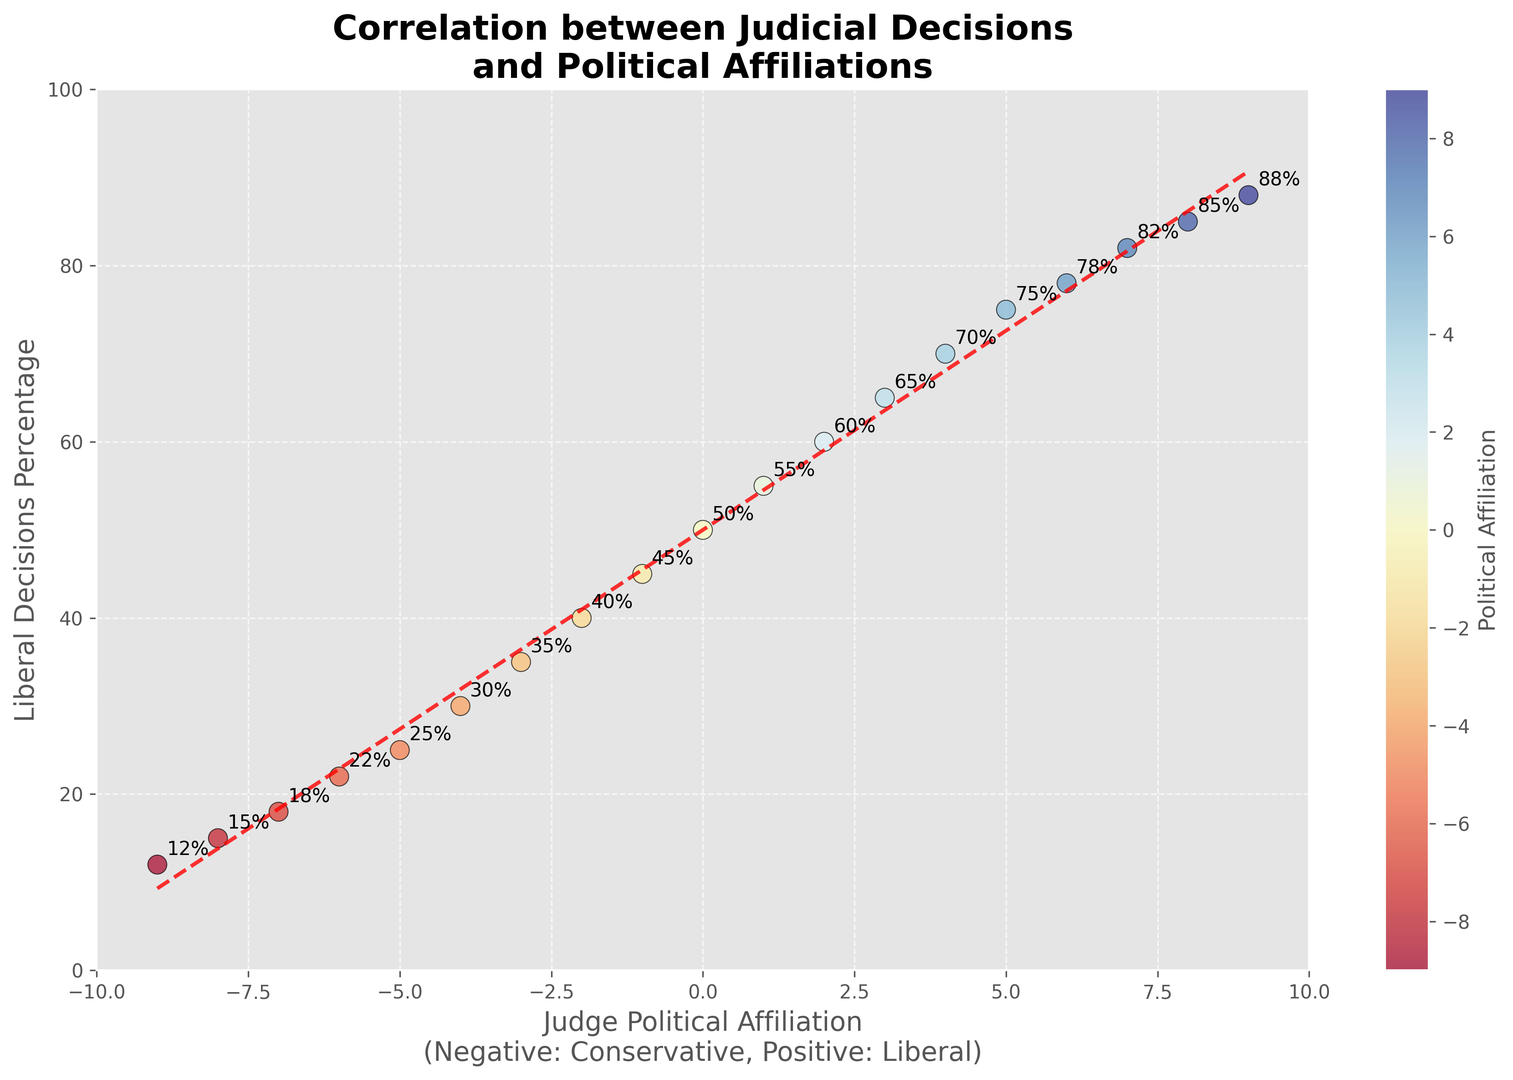What's the overall trend in the percentage of liberal decisions as the judge's political affiliation becomes more liberal? The trend can be seen from the scatter plot where liberal decisions percentage increases as the judge's political affiliation moves from conservative (negative values) to liberal (positive values). This trend is emphasized by the red dashed line (linear fit) in the plot.
Answer: Increases What range of political affiliations shows judges making around 50% liberal decisions? Observing the scatter plot, judges with political affiliations near 0 (neutral) make around 50% liberal decisions.
Answer: Around 0 Which judge political affiliation has the highest percentage of liberal decisions? The scatter plot indicates that the highest percentage of liberal decisions, 88%, corresponds to the judge with a political affiliation of 9.
Answer: 9 Can you identify the approximate slope of the red dashed trend line? By looking at the red dashed trend line (linear fit), the slope can be roughly estimated. It seems to rise by about 10 units on the y-axis for every 1 unit on the x-axis. The actual slope might be around 8-10.
Answer: 8-10 Is the trend between political affiliation and liberal decisions positive or negative? The red dashed trend line shows an upward trajectory from left to right, indicating a positive correlation between political affiliation and liberal decisions.
Answer: Positive Which judge political affiliation corresponds to around 75% of liberal decisions? According to the scatter plot, around 75% of liberal decisions correspond to the political affiliation of around 5.
Answer: 5 How does the liberal decisions percentage vary among judges with political affiliations between -5 and 5? Observing this range on the scatter plot, judges with political affiliations between -5 and 5 have their liberal decisions percentages increasing from 25% to 75%.
Answer: 25% to 75% What does the color gradient in the scatter plot represent? The color gradient in the scatter plot represents the political affiliation of the judges, ranging from blue (conservative) to red (liberal) through yellow.
Answer: Political affiliation Which group shows more variance in liberal decision percentages, conservative or liberal judges? By comparing the spread of points, conservative judges (negative values) show a more compressed range (12%-45%), whereas liberal judges (positive values) span from 50%-88%. Therefore, liberal judges show more variance.
Answer: Liberal judges 